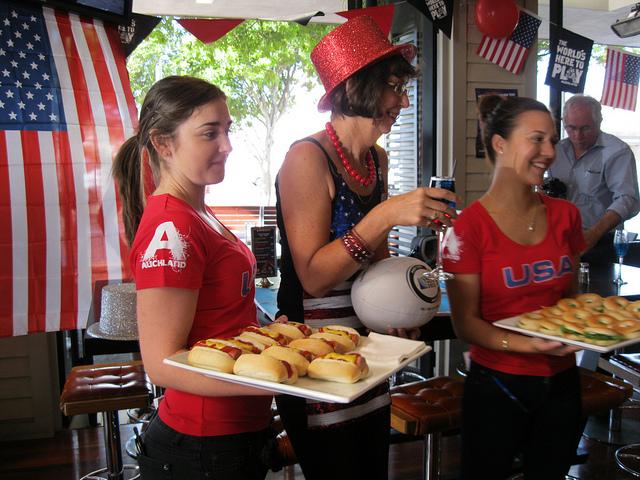Are these people before a group?
Short answer required. Yes. What are they serving?
Be succinct. Hot dogs. What color is the statue's dress jacket?
Concise answer only. Red. What country are they celebrating?
Be succinct. Usa. 